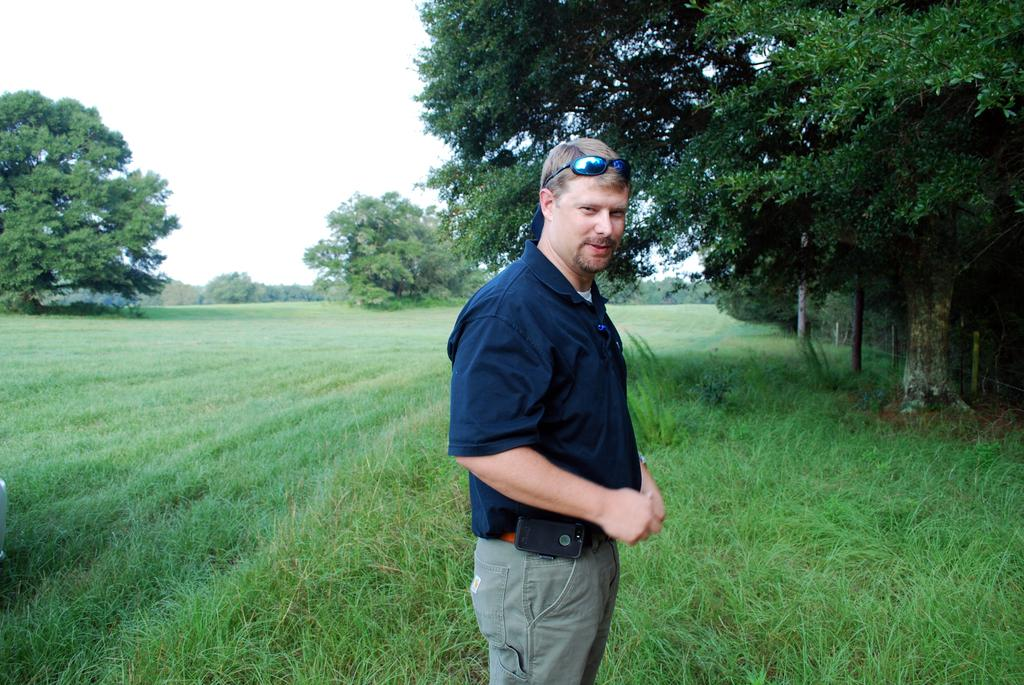What is present in the image? There is a person in the image. What is the person wearing on their head? The person is wearing goggles on their head. What type of terrain is visible in the image? There is grass on the ground in the image. What can be seen in the background of the image? There are trees in the background of the image. What is visible above the person and trees? The sky is visible in the image. How many horses are present in the image? There are no horses present in the image; it only features a person wearing goggles. What type of air can be seen in the image? The image does not show any specific type of air; it simply shows the sky. 